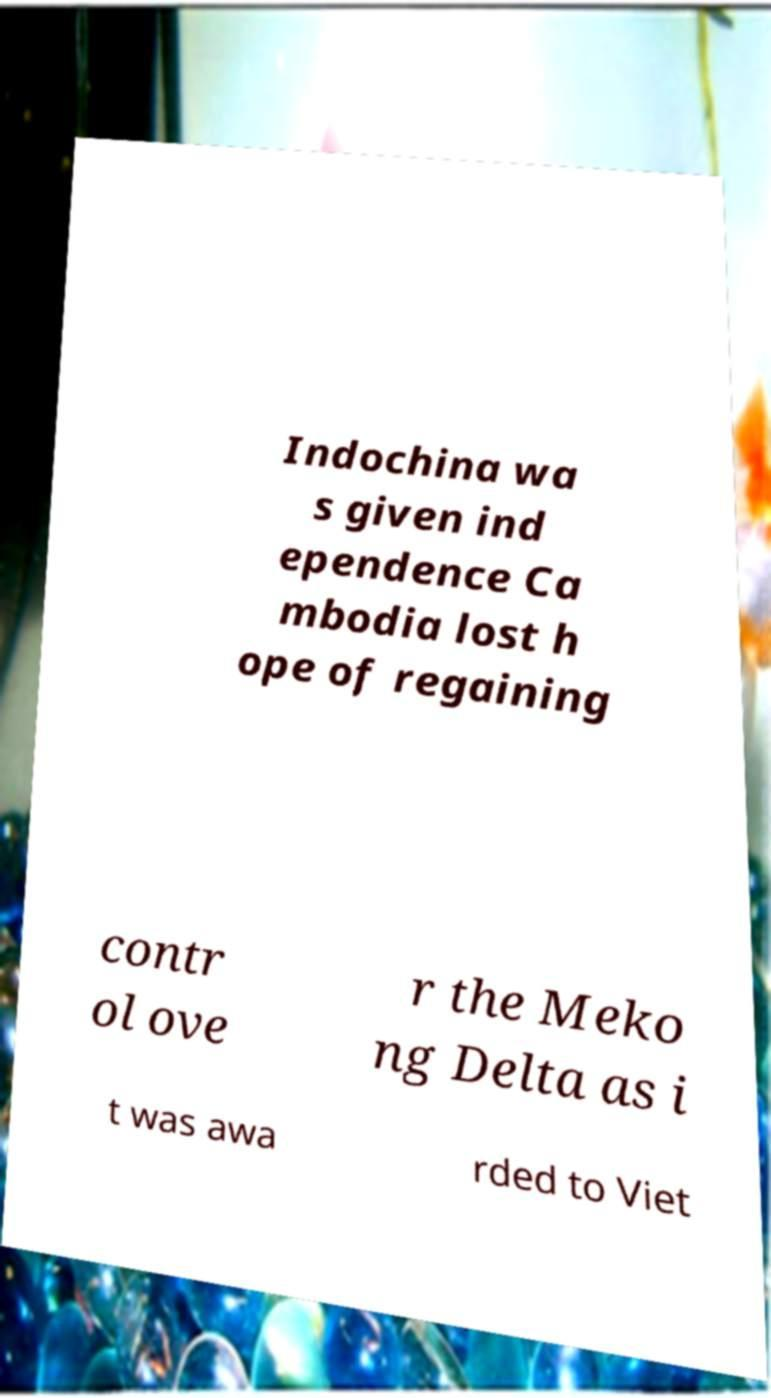For documentation purposes, I need the text within this image transcribed. Could you provide that? Indochina wa s given ind ependence Ca mbodia lost h ope of regaining contr ol ove r the Meko ng Delta as i t was awa rded to Viet 